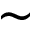<formula> <loc_0><loc_0><loc_500><loc_500>\sim</formula> 